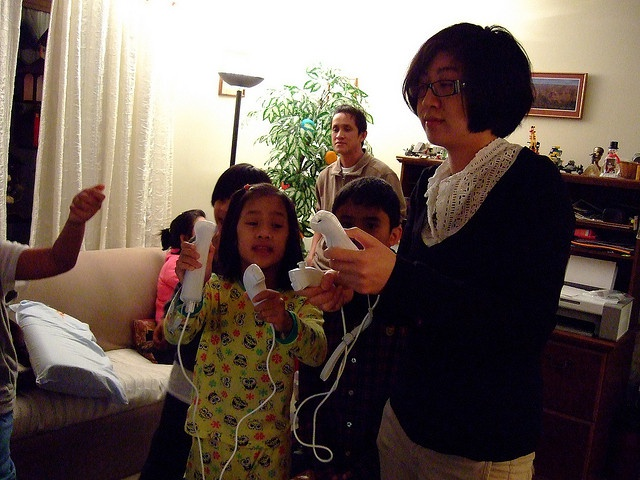Describe the objects in this image and their specific colors. I can see people in beige, black, maroon, and gray tones, people in beige, black, maroon, olive, and gray tones, couch in beige, black, gray, lightgray, and brown tones, people in beige, black, maroon, and gray tones, and potted plant in beige, ivory, olive, and black tones in this image. 